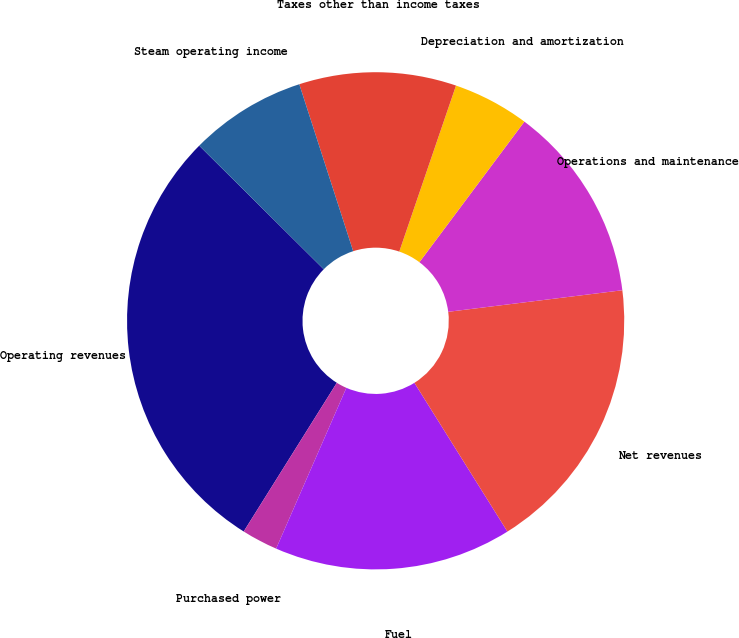Convert chart. <chart><loc_0><loc_0><loc_500><loc_500><pie_chart><fcel>Operating revenues<fcel>Purchased power<fcel>Fuel<fcel>Net revenues<fcel>Operations and maintenance<fcel>Depreciation and amortization<fcel>Taxes other than income taxes<fcel>Steam operating income<nl><fcel>28.54%<fcel>2.35%<fcel>15.45%<fcel>18.07%<fcel>12.83%<fcel>4.97%<fcel>10.21%<fcel>7.59%<nl></chart> 